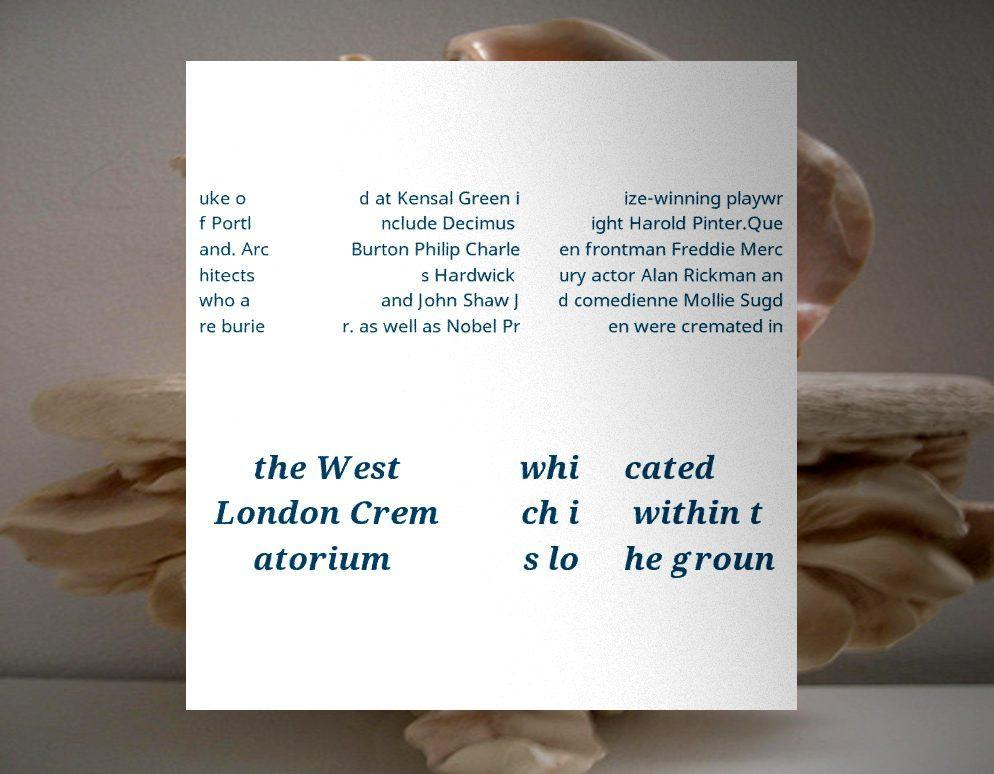Can you accurately transcribe the text from the provided image for me? uke o f Portl and. Arc hitects who a re burie d at Kensal Green i nclude Decimus Burton Philip Charle s Hardwick and John Shaw J r. as well as Nobel Pr ize-winning playwr ight Harold Pinter.Que en frontman Freddie Merc ury actor Alan Rickman an d comedienne Mollie Sugd en were cremated in the West London Crem atorium whi ch i s lo cated within t he groun 